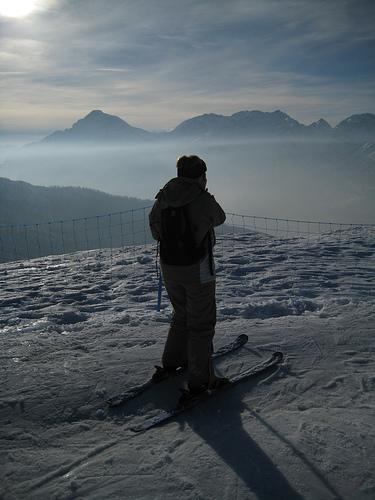Give a general description of the environment surrounding the main subject. The man is skiing amidst mountains, blue sky, sun, snow-covered ground, plastic fence, and snow on a hillside. Briefly describe the skier's outfit. The skier is wearing a one-piece snow suit with a hood, a backpack, a warm headband or ear protectors, a winter hat, a tan snow jacket, and tan snow pants. Describe the weather in this image based on visible elements. The weather appears to be a mix of sunny and cloudy, with a blue sky, sun shining brightly, thin white clouds, and white mist in the distance. Examine the skier's equipment and mention the two items on his feet. The skier has two skis, one on his right foot and the other on his left foot, both covered in snow. What sort of barrier is set up to keep skiers safe in the image? There is a blue plastic fence, also known as a safety net, erected in the snow to keep skiers safe. Identify the central figure in the image and the type of clothing they're wearing. A man wearing a one-piece snow suit, a backpack, and a warm headband is the central figure in the image. What is the sentiment or mood conveyed by the image based on the given captions? The image conveys a sense of adventure, enjoyment, and a peaceful winter day amidst nature while skiing on a snow-covered hill overlooking a mountain range. What is notable about the snow on the ground based on given captions? The snow on the ground is white, has tracks and pits in it, and it is covering a hillside. State the number of objects under the category 'mountain range' described in the given captions. There are five objects under the 'mountain range' category: mountains in the distance, a mountain range view, dark mountain range in the distance, tree lined mountain range, and tips of mountains in distance. 